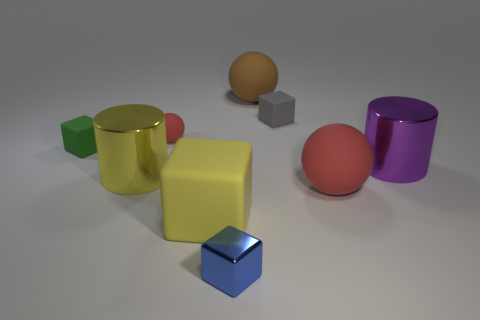How many big objects are either yellow cylinders or brown objects?
Your answer should be compact. 2. Is there a cylinder that is in front of the metallic cylinder that is left of the large purple cylinder?
Your response must be concise. No. Are there any tiny cyan shiny balls?
Keep it short and to the point. No. There is a rubber sphere that is left of the small object in front of the purple metallic object; what is its color?
Your answer should be very brief. Red. There is a small blue thing that is the same shape as the gray rubber thing; what is it made of?
Your response must be concise. Metal. How many blue shiny blocks are the same size as the blue thing?
Your response must be concise. 0. There is a gray thing that is the same material as the large yellow cube; what size is it?
Give a very brief answer. Small. What number of green rubber objects are the same shape as the big yellow rubber thing?
Your answer should be compact. 1. How many gray rubber cylinders are there?
Provide a short and direct response. 0. Does the red matte object that is behind the big red rubber sphere have the same shape as the blue object?
Offer a terse response. No. 